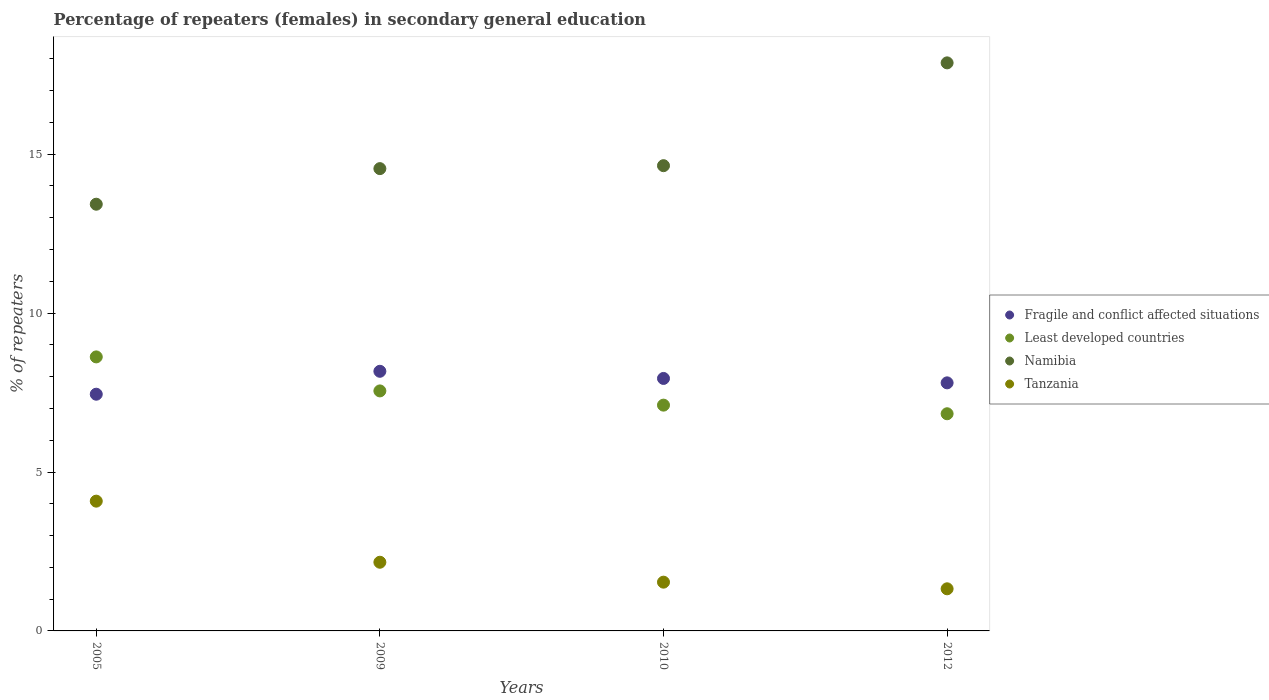How many different coloured dotlines are there?
Offer a terse response. 4. Is the number of dotlines equal to the number of legend labels?
Your answer should be very brief. Yes. What is the percentage of female repeaters in Namibia in 2010?
Provide a succinct answer. 14.64. Across all years, what is the maximum percentage of female repeaters in Tanzania?
Provide a short and direct response. 4.08. Across all years, what is the minimum percentage of female repeaters in Fragile and conflict affected situations?
Your answer should be compact. 7.45. What is the total percentage of female repeaters in Tanzania in the graph?
Offer a very short reply. 9.1. What is the difference between the percentage of female repeaters in Tanzania in 2005 and that in 2010?
Your answer should be compact. 2.55. What is the difference between the percentage of female repeaters in Namibia in 2005 and the percentage of female repeaters in Tanzania in 2010?
Your answer should be compact. 11.89. What is the average percentage of female repeaters in Tanzania per year?
Keep it short and to the point. 2.28. In the year 2010, what is the difference between the percentage of female repeaters in Fragile and conflict affected situations and percentage of female repeaters in Tanzania?
Your response must be concise. 6.41. In how many years, is the percentage of female repeaters in Tanzania greater than 17 %?
Offer a very short reply. 0. What is the ratio of the percentage of female repeaters in Fragile and conflict affected situations in 2005 to that in 2009?
Keep it short and to the point. 0.91. Is the percentage of female repeaters in Namibia in 2005 less than that in 2010?
Provide a short and direct response. Yes. Is the difference between the percentage of female repeaters in Fragile and conflict affected situations in 2010 and 2012 greater than the difference between the percentage of female repeaters in Tanzania in 2010 and 2012?
Keep it short and to the point. No. What is the difference between the highest and the second highest percentage of female repeaters in Tanzania?
Ensure brevity in your answer.  1.92. What is the difference between the highest and the lowest percentage of female repeaters in Least developed countries?
Keep it short and to the point. 1.79. In how many years, is the percentage of female repeaters in Tanzania greater than the average percentage of female repeaters in Tanzania taken over all years?
Make the answer very short. 1. Is it the case that in every year, the sum of the percentage of female repeaters in Namibia and percentage of female repeaters in Least developed countries  is greater than the sum of percentage of female repeaters in Tanzania and percentage of female repeaters in Fragile and conflict affected situations?
Your answer should be compact. Yes. Does the percentage of female repeaters in Least developed countries monotonically increase over the years?
Provide a short and direct response. No. How many dotlines are there?
Offer a terse response. 4. How many years are there in the graph?
Make the answer very short. 4. What is the difference between two consecutive major ticks on the Y-axis?
Your response must be concise. 5. Are the values on the major ticks of Y-axis written in scientific E-notation?
Offer a terse response. No. Does the graph contain grids?
Your answer should be very brief. No. Where does the legend appear in the graph?
Your answer should be compact. Center right. What is the title of the graph?
Offer a very short reply. Percentage of repeaters (females) in secondary general education. Does "Costa Rica" appear as one of the legend labels in the graph?
Give a very brief answer. No. What is the label or title of the X-axis?
Make the answer very short. Years. What is the label or title of the Y-axis?
Keep it short and to the point. % of repeaters. What is the % of repeaters in Fragile and conflict affected situations in 2005?
Provide a short and direct response. 7.45. What is the % of repeaters of Least developed countries in 2005?
Your response must be concise. 8.62. What is the % of repeaters of Namibia in 2005?
Your answer should be compact. 13.43. What is the % of repeaters of Tanzania in 2005?
Your answer should be compact. 4.08. What is the % of repeaters of Fragile and conflict affected situations in 2009?
Provide a short and direct response. 8.17. What is the % of repeaters of Least developed countries in 2009?
Your answer should be compact. 7.55. What is the % of repeaters in Namibia in 2009?
Keep it short and to the point. 14.55. What is the % of repeaters in Tanzania in 2009?
Give a very brief answer. 2.16. What is the % of repeaters in Fragile and conflict affected situations in 2010?
Ensure brevity in your answer.  7.94. What is the % of repeaters of Least developed countries in 2010?
Offer a very short reply. 7.1. What is the % of repeaters of Namibia in 2010?
Provide a short and direct response. 14.64. What is the % of repeaters of Tanzania in 2010?
Your answer should be very brief. 1.53. What is the % of repeaters of Fragile and conflict affected situations in 2012?
Provide a short and direct response. 7.81. What is the % of repeaters in Least developed countries in 2012?
Your response must be concise. 6.83. What is the % of repeaters of Namibia in 2012?
Keep it short and to the point. 17.87. What is the % of repeaters of Tanzania in 2012?
Your response must be concise. 1.33. Across all years, what is the maximum % of repeaters of Fragile and conflict affected situations?
Your answer should be very brief. 8.17. Across all years, what is the maximum % of repeaters of Least developed countries?
Keep it short and to the point. 8.62. Across all years, what is the maximum % of repeaters in Namibia?
Keep it short and to the point. 17.87. Across all years, what is the maximum % of repeaters of Tanzania?
Ensure brevity in your answer.  4.08. Across all years, what is the minimum % of repeaters of Fragile and conflict affected situations?
Ensure brevity in your answer.  7.45. Across all years, what is the minimum % of repeaters in Least developed countries?
Provide a short and direct response. 6.83. Across all years, what is the minimum % of repeaters of Namibia?
Offer a terse response. 13.43. Across all years, what is the minimum % of repeaters of Tanzania?
Your answer should be compact. 1.33. What is the total % of repeaters of Fragile and conflict affected situations in the graph?
Ensure brevity in your answer.  31.37. What is the total % of repeaters in Least developed countries in the graph?
Make the answer very short. 30.11. What is the total % of repeaters in Namibia in the graph?
Provide a short and direct response. 60.49. What is the total % of repeaters of Tanzania in the graph?
Keep it short and to the point. 9.1. What is the difference between the % of repeaters in Fragile and conflict affected situations in 2005 and that in 2009?
Ensure brevity in your answer.  -0.72. What is the difference between the % of repeaters of Least developed countries in 2005 and that in 2009?
Provide a short and direct response. 1.07. What is the difference between the % of repeaters in Namibia in 2005 and that in 2009?
Offer a terse response. -1.12. What is the difference between the % of repeaters of Tanzania in 2005 and that in 2009?
Make the answer very short. 1.92. What is the difference between the % of repeaters of Fragile and conflict affected situations in 2005 and that in 2010?
Your response must be concise. -0.5. What is the difference between the % of repeaters of Least developed countries in 2005 and that in 2010?
Offer a very short reply. 1.52. What is the difference between the % of repeaters of Namibia in 2005 and that in 2010?
Provide a succinct answer. -1.21. What is the difference between the % of repeaters in Tanzania in 2005 and that in 2010?
Ensure brevity in your answer.  2.55. What is the difference between the % of repeaters of Fragile and conflict affected situations in 2005 and that in 2012?
Provide a succinct answer. -0.36. What is the difference between the % of repeaters of Least developed countries in 2005 and that in 2012?
Offer a very short reply. 1.79. What is the difference between the % of repeaters in Namibia in 2005 and that in 2012?
Your answer should be compact. -4.45. What is the difference between the % of repeaters of Tanzania in 2005 and that in 2012?
Make the answer very short. 2.76. What is the difference between the % of repeaters in Fragile and conflict affected situations in 2009 and that in 2010?
Keep it short and to the point. 0.23. What is the difference between the % of repeaters in Least developed countries in 2009 and that in 2010?
Your answer should be very brief. 0.45. What is the difference between the % of repeaters of Namibia in 2009 and that in 2010?
Provide a succinct answer. -0.09. What is the difference between the % of repeaters in Tanzania in 2009 and that in 2010?
Keep it short and to the point. 0.63. What is the difference between the % of repeaters in Fragile and conflict affected situations in 2009 and that in 2012?
Keep it short and to the point. 0.36. What is the difference between the % of repeaters of Least developed countries in 2009 and that in 2012?
Offer a very short reply. 0.72. What is the difference between the % of repeaters in Namibia in 2009 and that in 2012?
Your answer should be very brief. -3.33. What is the difference between the % of repeaters of Tanzania in 2009 and that in 2012?
Give a very brief answer. 0.84. What is the difference between the % of repeaters of Fragile and conflict affected situations in 2010 and that in 2012?
Your response must be concise. 0.14. What is the difference between the % of repeaters in Least developed countries in 2010 and that in 2012?
Make the answer very short. 0.27. What is the difference between the % of repeaters of Namibia in 2010 and that in 2012?
Keep it short and to the point. -3.23. What is the difference between the % of repeaters in Tanzania in 2010 and that in 2012?
Make the answer very short. 0.21. What is the difference between the % of repeaters in Fragile and conflict affected situations in 2005 and the % of repeaters in Least developed countries in 2009?
Make the answer very short. -0.1. What is the difference between the % of repeaters of Fragile and conflict affected situations in 2005 and the % of repeaters of Namibia in 2009?
Your answer should be very brief. -7.1. What is the difference between the % of repeaters of Fragile and conflict affected situations in 2005 and the % of repeaters of Tanzania in 2009?
Your answer should be very brief. 5.29. What is the difference between the % of repeaters in Least developed countries in 2005 and the % of repeaters in Namibia in 2009?
Your answer should be very brief. -5.92. What is the difference between the % of repeaters of Least developed countries in 2005 and the % of repeaters of Tanzania in 2009?
Your response must be concise. 6.46. What is the difference between the % of repeaters of Namibia in 2005 and the % of repeaters of Tanzania in 2009?
Keep it short and to the point. 11.27. What is the difference between the % of repeaters of Fragile and conflict affected situations in 2005 and the % of repeaters of Least developed countries in 2010?
Your response must be concise. 0.34. What is the difference between the % of repeaters of Fragile and conflict affected situations in 2005 and the % of repeaters of Namibia in 2010?
Give a very brief answer. -7.19. What is the difference between the % of repeaters in Fragile and conflict affected situations in 2005 and the % of repeaters in Tanzania in 2010?
Your response must be concise. 5.91. What is the difference between the % of repeaters of Least developed countries in 2005 and the % of repeaters of Namibia in 2010?
Provide a short and direct response. -6.02. What is the difference between the % of repeaters in Least developed countries in 2005 and the % of repeaters in Tanzania in 2010?
Provide a short and direct response. 7.09. What is the difference between the % of repeaters of Namibia in 2005 and the % of repeaters of Tanzania in 2010?
Your answer should be very brief. 11.89. What is the difference between the % of repeaters of Fragile and conflict affected situations in 2005 and the % of repeaters of Least developed countries in 2012?
Offer a terse response. 0.61. What is the difference between the % of repeaters in Fragile and conflict affected situations in 2005 and the % of repeaters in Namibia in 2012?
Your answer should be very brief. -10.43. What is the difference between the % of repeaters of Fragile and conflict affected situations in 2005 and the % of repeaters of Tanzania in 2012?
Your answer should be very brief. 6.12. What is the difference between the % of repeaters in Least developed countries in 2005 and the % of repeaters in Namibia in 2012?
Ensure brevity in your answer.  -9.25. What is the difference between the % of repeaters in Least developed countries in 2005 and the % of repeaters in Tanzania in 2012?
Provide a short and direct response. 7.3. What is the difference between the % of repeaters in Namibia in 2005 and the % of repeaters in Tanzania in 2012?
Keep it short and to the point. 12.1. What is the difference between the % of repeaters in Fragile and conflict affected situations in 2009 and the % of repeaters in Least developed countries in 2010?
Your answer should be very brief. 1.06. What is the difference between the % of repeaters in Fragile and conflict affected situations in 2009 and the % of repeaters in Namibia in 2010?
Offer a very short reply. -6.47. What is the difference between the % of repeaters of Fragile and conflict affected situations in 2009 and the % of repeaters of Tanzania in 2010?
Keep it short and to the point. 6.64. What is the difference between the % of repeaters of Least developed countries in 2009 and the % of repeaters of Namibia in 2010?
Keep it short and to the point. -7.09. What is the difference between the % of repeaters of Least developed countries in 2009 and the % of repeaters of Tanzania in 2010?
Offer a terse response. 6.02. What is the difference between the % of repeaters of Namibia in 2009 and the % of repeaters of Tanzania in 2010?
Your answer should be compact. 13.01. What is the difference between the % of repeaters in Fragile and conflict affected situations in 2009 and the % of repeaters in Least developed countries in 2012?
Make the answer very short. 1.34. What is the difference between the % of repeaters of Fragile and conflict affected situations in 2009 and the % of repeaters of Namibia in 2012?
Provide a short and direct response. -9.7. What is the difference between the % of repeaters of Fragile and conflict affected situations in 2009 and the % of repeaters of Tanzania in 2012?
Give a very brief answer. 6.84. What is the difference between the % of repeaters in Least developed countries in 2009 and the % of repeaters in Namibia in 2012?
Provide a short and direct response. -10.32. What is the difference between the % of repeaters of Least developed countries in 2009 and the % of repeaters of Tanzania in 2012?
Provide a short and direct response. 6.23. What is the difference between the % of repeaters of Namibia in 2009 and the % of repeaters of Tanzania in 2012?
Offer a terse response. 13.22. What is the difference between the % of repeaters of Fragile and conflict affected situations in 2010 and the % of repeaters of Least developed countries in 2012?
Provide a short and direct response. 1.11. What is the difference between the % of repeaters of Fragile and conflict affected situations in 2010 and the % of repeaters of Namibia in 2012?
Your answer should be compact. -9.93. What is the difference between the % of repeaters of Fragile and conflict affected situations in 2010 and the % of repeaters of Tanzania in 2012?
Provide a short and direct response. 6.62. What is the difference between the % of repeaters of Least developed countries in 2010 and the % of repeaters of Namibia in 2012?
Your answer should be very brief. -10.77. What is the difference between the % of repeaters of Least developed countries in 2010 and the % of repeaters of Tanzania in 2012?
Your answer should be very brief. 5.78. What is the difference between the % of repeaters of Namibia in 2010 and the % of repeaters of Tanzania in 2012?
Your response must be concise. 13.31. What is the average % of repeaters in Fragile and conflict affected situations per year?
Make the answer very short. 7.84. What is the average % of repeaters in Least developed countries per year?
Ensure brevity in your answer.  7.53. What is the average % of repeaters in Namibia per year?
Provide a short and direct response. 15.12. What is the average % of repeaters in Tanzania per year?
Your answer should be compact. 2.28. In the year 2005, what is the difference between the % of repeaters of Fragile and conflict affected situations and % of repeaters of Least developed countries?
Ensure brevity in your answer.  -1.17. In the year 2005, what is the difference between the % of repeaters in Fragile and conflict affected situations and % of repeaters in Namibia?
Your answer should be very brief. -5.98. In the year 2005, what is the difference between the % of repeaters in Fragile and conflict affected situations and % of repeaters in Tanzania?
Make the answer very short. 3.36. In the year 2005, what is the difference between the % of repeaters in Least developed countries and % of repeaters in Namibia?
Your answer should be very brief. -4.8. In the year 2005, what is the difference between the % of repeaters of Least developed countries and % of repeaters of Tanzania?
Make the answer very short. 4.54. In the year 2005, what is the difference between the % of repeaters in Namibia and % of repeaters in Tanzania?
Your answer should be very brief. 9.34. In the year 2009, what is the difference between the % of repeaters in Fragile and conflict affected situations and % of repeaters in Least developed countries?
Make the answer very short. 0.62. In the year 2009, what is the difference between the % of repeaters in Fragile and conflict affected situations and % of repeaters in Namibia?
Your answer should be very brief. -6.38. In the year 2009, what is the difference between the % of repeaters of Fragile and conflict affected situations and % of repeaters of Tanzania?
Make the answer very short. 6.01. In the year 2009, what is the difference between the % of repeaters of Least developed countries and % of repeaters of Namibia?
Your answer should be very brief. -6.99. In the year 2009, what is the difference between the % of repeaters in Least developed countries and % of repeaters in Tanzania?
Your answer should be very brief. 5.39. In the year 2009, what is the difference between the % of repeaters of Namibia and % of repeaters of Tanzania?
Offer a terse response. 12.39. In the year 2010, what is the difference between the % of repeaters in Fragile and conflict affected situations and % of repeaters in Least developed countries?
Your response must be concise. 0.84. In the year 2010, what is the difference between the % of repeaters in Fragile and conflict affected situations and % of repeaters in Namibia?
Make the answer very short. -6.7. In the year 2010, what is the difference between the % of repeaters of Fragile and conflict affected situations and % of repeaters of Tanzania?
Your response must be concise. 6.41. In the year 2010, what is the difference between the % of repeaters in Least developed countries and % of repeaters in Namibia?
Your response must be concise. -7.54. In the year 2010, what is the difference between the % of repeaters in Least developed countries and % of repeaters in Tanzania?
Give a very brief answer. 5.57. In the year 2010, what is the difference between the % of repeaters in Namibia and % of repeaters in Tanzania?
Your answer should be very brief. 13.11. In the year 2012, what is the difference between the % of repeaters of Fragile and conflict affected situations and % of repeaters of Least developed countries?
Make the answer very short. 0.97. In the year 2012, what is the difference between the % of repeaters of Fragile and conflict affected situations and % of repeaters of Namibia?
Give a very brief answer. -10.07. In the year 2012, what is the difference between the % of repeaters of Fragile and conflict affected situations and % of repeaters of Tanzania?
Keep it short and to the point. 6.48. In the year 2012, what is the difference between the % of repeaters in Least developed countries and % of repeaters in Namibia?
Keep it short and to the point. -11.04. In the year 2012, what is the difference between the % of repeaters in Least developed countries and % of repeaters in Tanzania?
Offer a very short reply. 5.51. In the year 2012, what is the difference between the % of repeaters in Namibia and % of repeaters in Tanzania?
Provide a succinct answer. 16.55. What is the ratio of the % of repeaters in Fragile and conflict affected situations in 2005 to that in 2009?
Ensure brevity in your answer.  0.91. What is the ratio of the % of repeaters of Least developed countries in 2005 to that in 2009?
Keep it short and to the point. 1.14. What is the ratio of the % of repeaters of Namibia in 2005 to that in 2009?
Provide a succinct answer. 0.92. What is the ratio of the % of repeaters in Tanzania in 2005 to that in 2009?
Give a very brief answer. 1.89. What is the ratio of the % of repeaters in Least developed countries in 2005 to that in 2010?
Ensure brevity in your answer.  1.21. What is the ratio of the % of repeaters of Namibia in 2005 to that in 2010?
Make the answer very short. 0.92. What is the ratio of the % of repeaters in Tanzania in 2005 to that in 2010?
Provide a succinct answer. 2.66. What is the ratio of the % of repeaters in Fragile and conflict affected situations in 2005 to that in 2012?
Provide a short and direct response. 0.95. What is the ratio of the % of repeaters of Least developed countries in 2005 to that in 2012?
Give a very brief answer. 1.26. What is the ratio of the % of repeaters in Namibia in 2005 to that in 2012?
Make the answer very short. 0.75. What is the ratio of the % of repeaters in Tanzania in 2005 to that in 2012?
Keep it short and to the point. 3.08. What is the ratio of the % of repeaters of Fragile and conflict affected situations in 2009 to that in 2010?
Give a very brief answer. 1.03. What is the ratio of the % of repeaters in Least developed countries in 2009 to that in 2010?
Offer a very short reply. 1.06. What is the ratio of the % of repeaters in Namibia in 2009 to that in 2010?
Your response must be concise. 0.99. What is the ratio of the % of repeaters in Tanzania in 2009 to that in 2010?
Give a very brief answer. 1.41. What is the ratio of the % of repeaters of Fragile and conflict affected situations in 2009 to that in 2012?
Provide a short and direct response. 1.05. What is the ratio of the % of repeaters in Least developed countries in 2009 to that in 2012?
Your answer should be very brief. 1.11. What is the ratio of the % of repeaters of Namibia in 2009 to that in 2012?
Offer a terse response. 0.81. What is the ratio of the % of repeaters in Tanzania in 2009 to that in 2012?
Offer a terse response. 1.63. What is the ratio of the % of repeaters in Fragile and conflict affected situations in 2010 to that in 2012?
Ensure brevity in your answer.  1.02. What is the ratio of the % of repeaters in Least developed countries in 2010 to that in 2012?
Provide a succinct answer. 1.04. What is the ratio of the % of repeaters in Namibia in 2010 to that in 2012?
Keep it short and to the point. 0.82. What is the ratio of the % of repeaters of Tanzania in 2010 to that in 2012?
Give a very brief answer. 1.16. What is the difference between the highest and the second highest % of repeaters in Fragile and conflict affected situations?
Your response must be concise. 0.23. What is the difference between the highest and the second highest % of repeaters in Least developed countries?
Your answer should be very brief. 1.07. What is the difference between the highest and the second highest % of repeaters of Namibia?
Provide a short and direct response. 3.23. What is the difference between the highest and the second highest % of repeaters of Tanzania?
Your answer should be very brief. 1.92. What is the difference between the highest and the lowest % of repeaters in Fragile and conflict affected situations?
Offer a very short reply. 0.72. What is the difference between the highest and the lowest % of repeaters in Least developed countries?
Keep it short and to the point. 1.79. What is the difference between the highest and the lowest % of repeaters in Namibia?
Your response must be concise. 4.45. What is the difference between the highest and the lowest % of repeaters in Tanzania?
Keep it short and to the point. 2.76. 